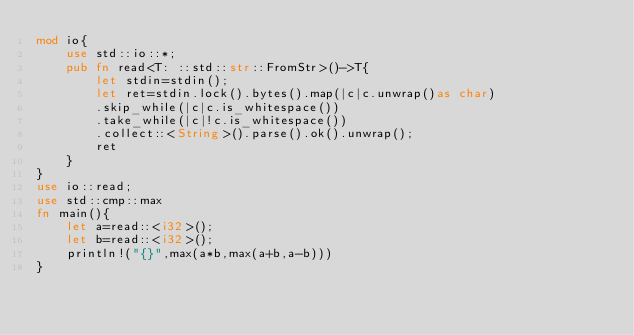<code> <loc_0><loc_0><loc_500><loc_500><_Rust_>mod io{
    use std::io::*;
    pub fn read<T: ::std::str::FromStr>()->T{
        let stdin=stdin();
        let ret=stdin.lock().bytes().map(|c|c.unwrap()as char)
        .skip_while(|c|c.is_whitespace())
        .take_while(|c|!c.is_whitespace())
        .collect::<String>().parse().ok().unwrap();
        ret
    }
}
use io::read;
use std::cmp::max
fn main(){
    let a=read::<i32>();
    let b=read::<i32>();
    println!("{}",max(a*b,max(a+b,a-b)))
}
</code> 